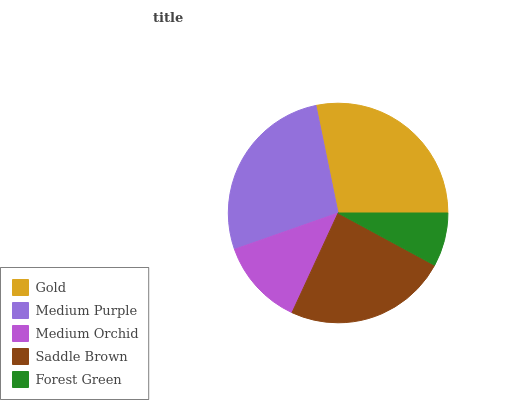Is Forest Green the minimum?
Answer yes or no. Yes. Is Gold the maximum?
Answer yes or no. Yes. Is Medium Purple the minimum?
Answer yes or no. No. Is Medium Purple the maximum?
Answer yes or no. No. Is Gold greater than Medium Purple?
Answer yes or no. Yes. Is Medium Purple less than Gold?
Answer yes or no. Yes. Is Medium Purple greater than Gold?
Answer yes or no. No. Is Gold less than Medium Purple?
Answer yes or no. No. Is Saddle Brown the high median?
Answer yes or no. Yes. Is Saddle Brown the low median?
Answer yes or no. Yes. Is Medium Orchid the high median?
Answer yes or no. No. Is Forest Green the low median?
Answer yes or no. No. 